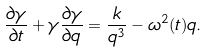<formula> <loc_0><loc_0><loc_500><loc_500>\frac { \partial \gamma } { \partial t } + \gamma \frac { \partial \gamma } { \partial q } = \frac { k } { q ^ { 3 } } - \omega ^ { 2 } ( t ) q .</formula> 